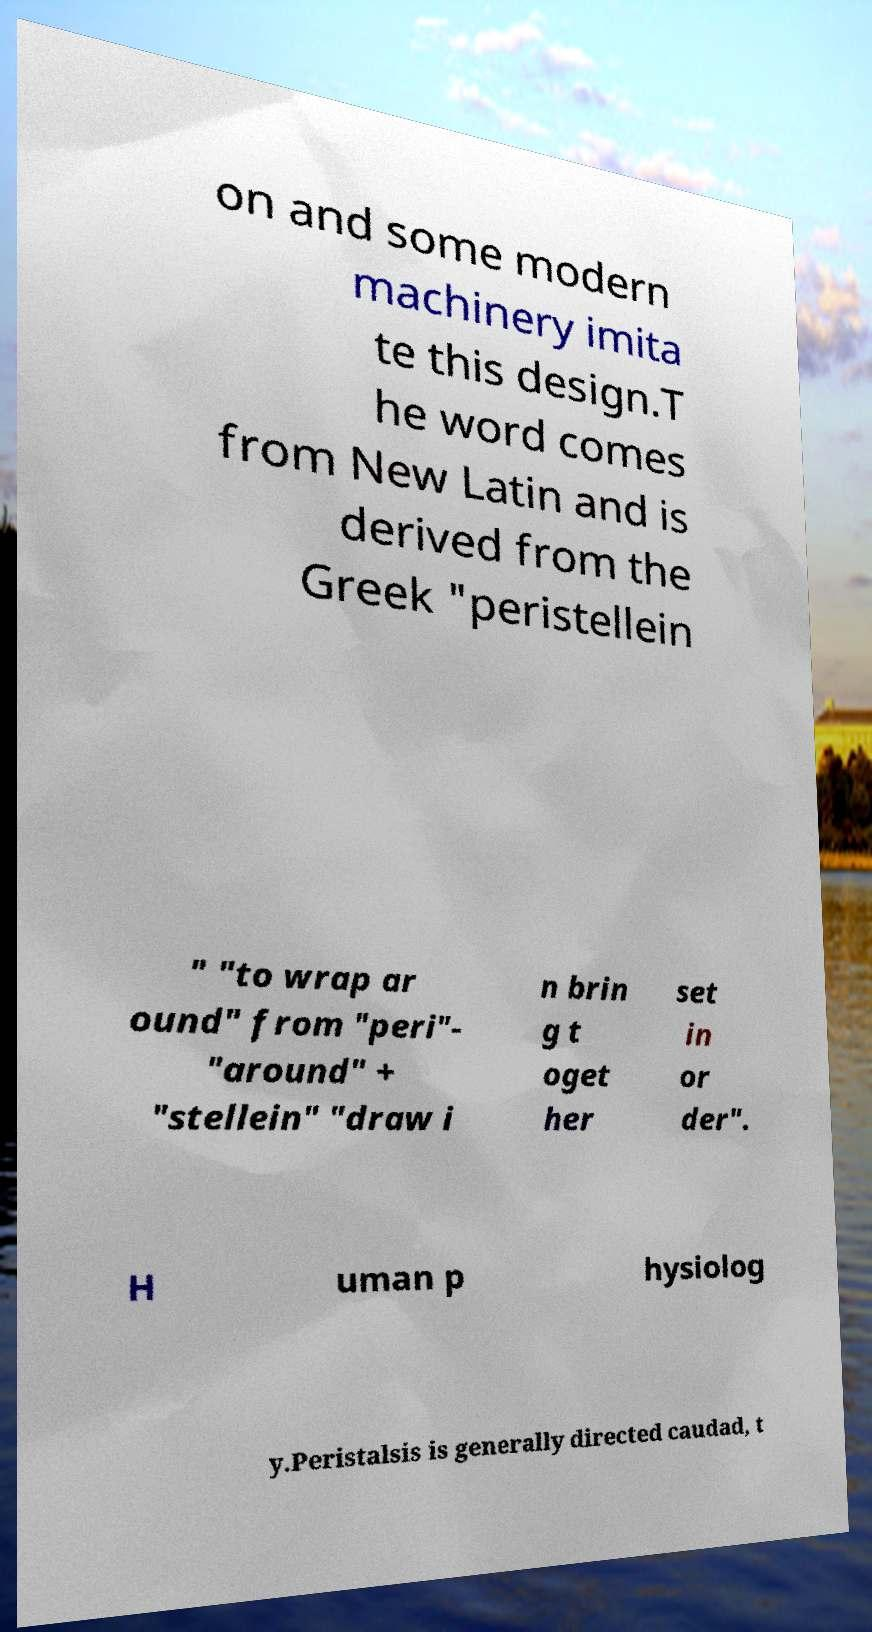Can you read and provide the text displayed in the image?This photo seems to have some interesting text. Can you extract and type it out for me? on and some modern machinery imita te this design.T he word comes from New Latin and is derived from the Greek "peristellein " "to wrap ar ound" from "peri"- "around" + "stellein" "draw i n brin g t oget her set in or der". H uman p hysiolog y.Peristalsis is generally directed caudad, t 